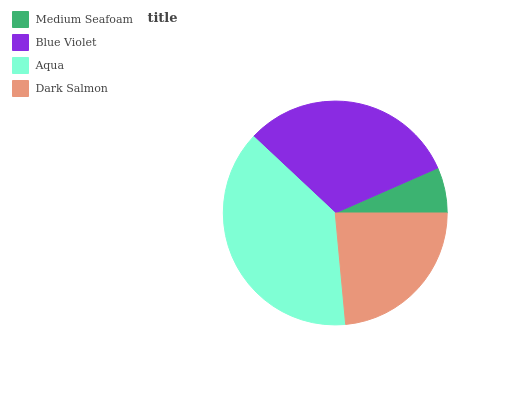Is Medium Seafoam the minimum?
Answer yes or no. Yes. Is Aqua the maximum?
Answer yes or no. Yes. Is Blue Violet the minimum?
Answer yes or no. No. Is Blue Violet the maximum?
Answer yes or no. No. Is Blue Violet greater than Medium Seafoam?
Answer yes or no. Yes. Is Medium Seafoam less than Blue Violet?
Answer yes or no. Yes. Is Medium Seafoam greater than Blue Violet?
Answer yes or no. No. Is Blue Violet less than Medium Seafoam?
Answer yes or no. No. Is Blue Violet the high median?
Answer yes or no. Yes. Is Dark Salmon the low median?
Answer yes or no. Yes. Is Medium Seafoam the high median?
Answer yes or no. No. Is Medium Seafoam the low median?
Answer yes or no. No. 